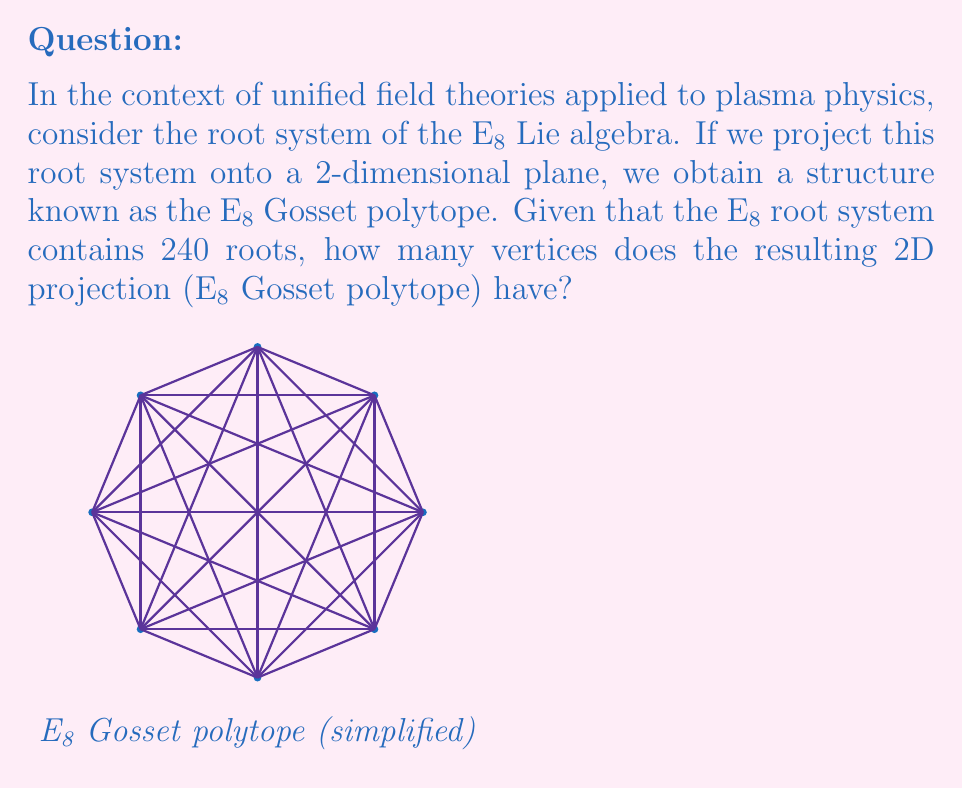Teach me how to tackle this problem. To solve this problem, let's break it down step-by-step:

1) The E8 Lie algebra is an exceptional Lie algebra of rank 8. Its root system consists of 240 roots in an 8-dimensional space.

2) When we project this 8-dimensional root system onto a 2-dimensional plane, we obtain the E8 Gosset polytope, also known as the E8 Petrie polygon.

3) In the projection process, some of the roots may overlap or coincide in the 2D plane. This means that the number of vertices in the 2D projection is not necessarily equal to the total number of roots.

4) The E8 Gosset polytope is known to have a very specific structure. It's a regular polygon in 2D with a particular number of vertices.

5) The number of vertices in this 2D projection is directly related to the rank of the E8 Lie algebra.

6) For exceptional Lie algebras, the number of vertices in the Gosset polytope (2D projection) is given by the formula:

   $$\text{Number of vertices} = 2n$$

   where $n$ is the rank of the Lie algebra.

7) Since E8 has rank 8, we can calculate:

   $$\text{Number of vertices} = 2 \cdot 8 = 16$$

Therefore, despite the E8 root system having 240 roots in 8-dimensional space, its 2D projection (the E8 Gosset polytope) has 16 vertices.

This result is significant in unified field theories and plasma physics as it demonstrates how high-dimensional symmetries (like those in E8) can manifest in lower-dimensional projections, potentially relating to observable phenomena in plasma systems.
Answer: 16 vertices 